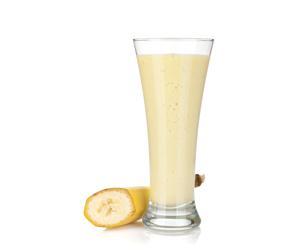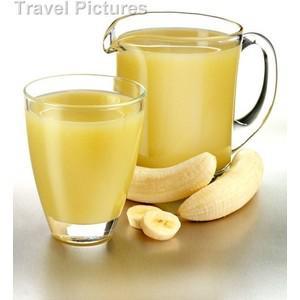The first image is the image on the left, the second image is the image on the right. For the images shown, is this caption "There are pieces of bananas without peel near a glass of juice." true? Answer yes or no. Yes. The first image is the image on the left, the second image is the image on the right. Examine the images to the left and right. Is the description "The right image contains at least one unpeeled banana." accurate? Answer yes or no. No. 